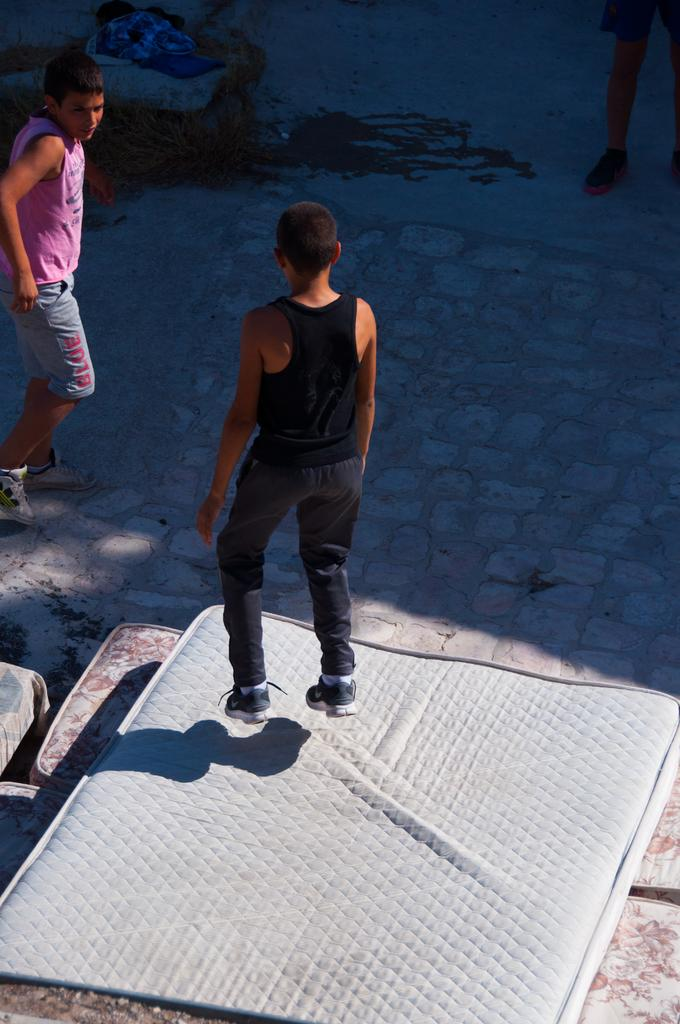How many people are in the image? There are people in the image, but the exact number is not specified. What is one person doing in the image? One person is jumping on a bed. What can be seen in the background of the image? There are other objects visible in the background, but their specific nature is not mentioned. What else is on the ground in the background? There are more beds on the ground in the background. What type of mint is growing on the bed in the image? There is no mention of mint or any plants in the image; it features people and beds. 